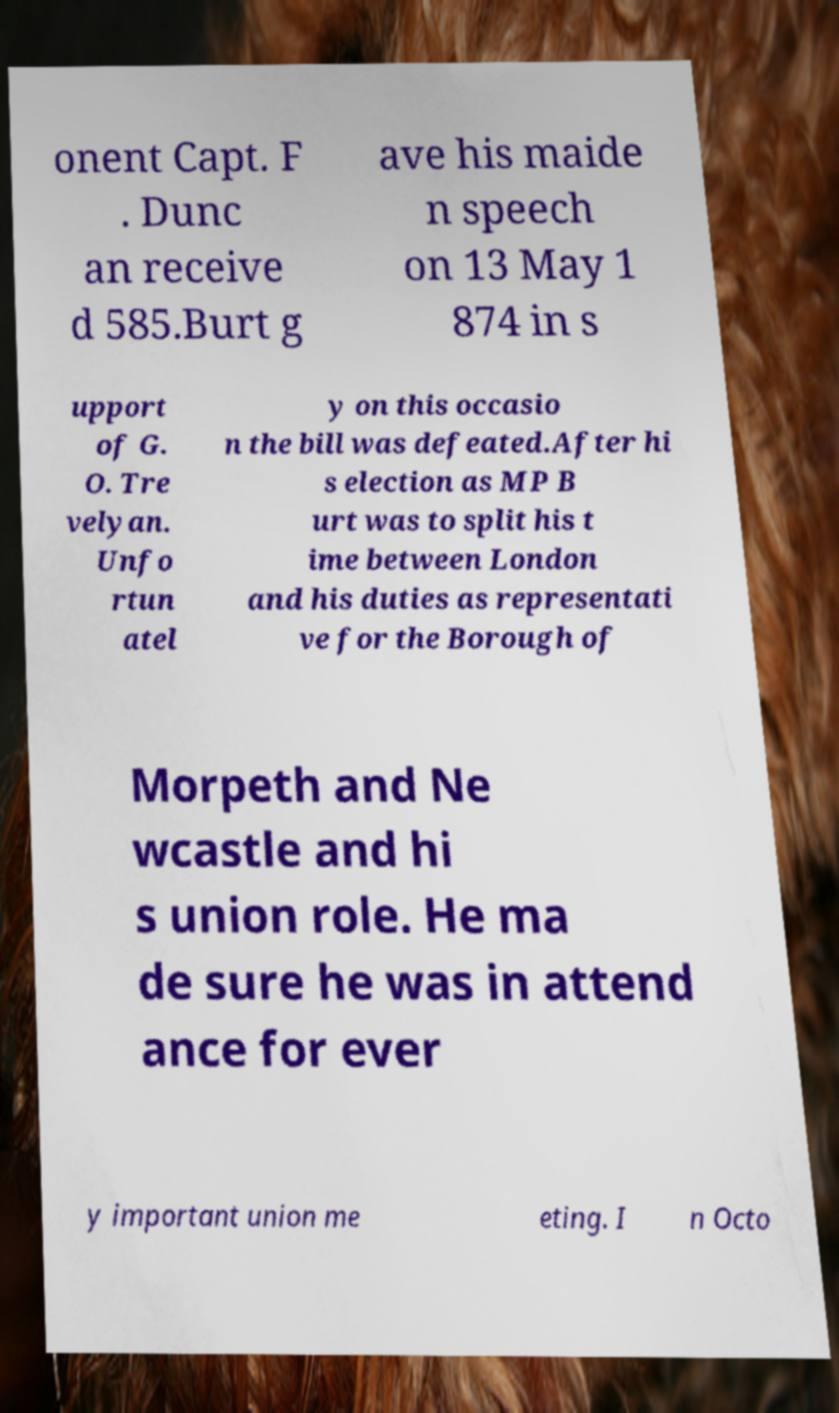Please identify and transcribe the text found in this image. onent Capt. F . Dunc an receive d 585.Burt g ave his maide n speech on 13 May 1 874 in s upport of G. O. Tre velyan. Unfo rtun atel y on this occasio n the bill was defeated.After hi s election as MP B urt was to split his t ime between London and his duties as representati ve for the Borough of Morpeth and Ne wcastle and hi s union role. He ma de sure he was in attend ance for ever y important union me eting. I n Octo 